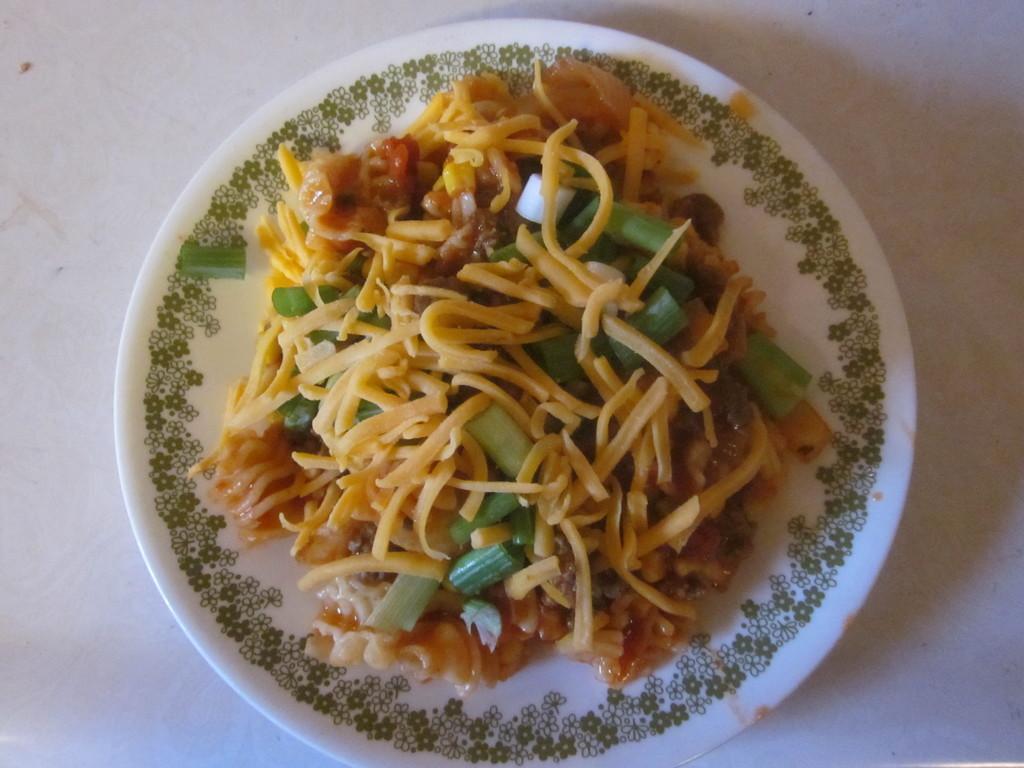How would you summarize this image in a sentence or two? In this image I can see food item on a white color plate. On the plate I can see a design. This plate is on a white color surface. 